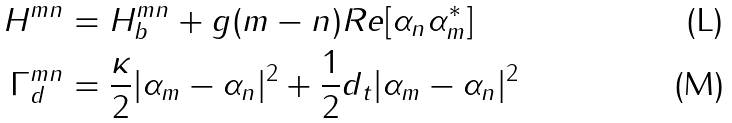Convert formula to latex. <formula><loc_0><loc_0><loc_500><loc_500>H ^ { m n } & = H _ { b } ^ { m n } + g ( m - n ) R e [ \alpha _ { n } \alpha _ { m } ^ { * } ] \\ \Gamma _ { d } ^ { m n } & = \frac { \kappa } { 2 } | \alpha _ { m } - \alpha _ { n } | ^ { 2 } + \frac { 1 } { 2 } d _ { t } | \alpha _ { m } - \alpha _ { n } | ^ { 2 }</formula> 